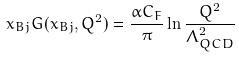Convert formula to latex. <formula><loc_0><loc_0><loc_500><loc_500>x _ { B j } G ( x _ { B j } , Q ^ { 2 } ) = \frac { \alpha C _ { F } } { \pi } \ln \frac { Q ^ { 2 } } { \Lambda _ { Q C D } ^ { 2 } }</formula> 